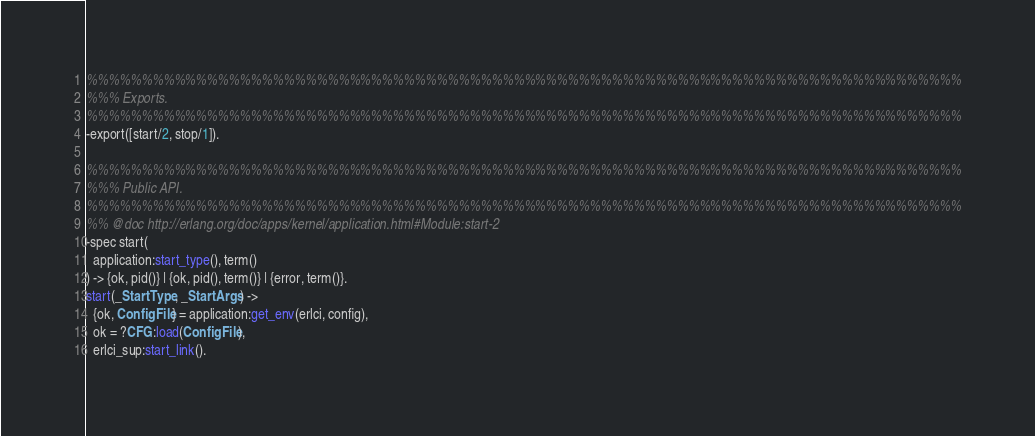<code> <loc_0><loc_0><loc_500><loc_500><_Erlang_>
%%%%%%%%%%%%%%%%%%%%%%%%%%%%%%%%%%%%%%%%%%%%%%%%%%%%%%%%%%%%%%%%%%%%%%%%%%%%%%%%
%%% Exports.
%%%%%%%%%%%%%%%%%%%%%%%%%%%%%%%%%%%%%%%%%%%%%%%%%%%%%%%%%%%%%%%%%%%%%%%%%%%%%%%%
-export([start/2, stop/1]).

%%%%%%%%%%%%%%%%%%%%%%%%%%%%%%%%%%%%%%%%%%%%%%%%%%%%%%%%%%%%%%%%%%%%%%%%%%%%%%%%
%%% Public API.
%%%%%%%%%%%%%%%%%%%%%%%%%%%%%%%%%%%%%%%%%%%%%%%%%%%%%%%%%%%%%%%%%%%%%%%%%%%%%%%%
%% @doc http://erlang.org/doc/apps/kernel/application.html#Module:start-2
-spec start(
  application:start_type(), term()
) -> {ok, pid()} | {ok, pid(), term()} | {error, term()}.
start(_StartType, _StartArgs) ->
  {ok, ConfigFile} = application:get_env(erlci, config),
  ok = ?CFG:load(ConfigFile),
  erlci_sup:start_link().
</code> 